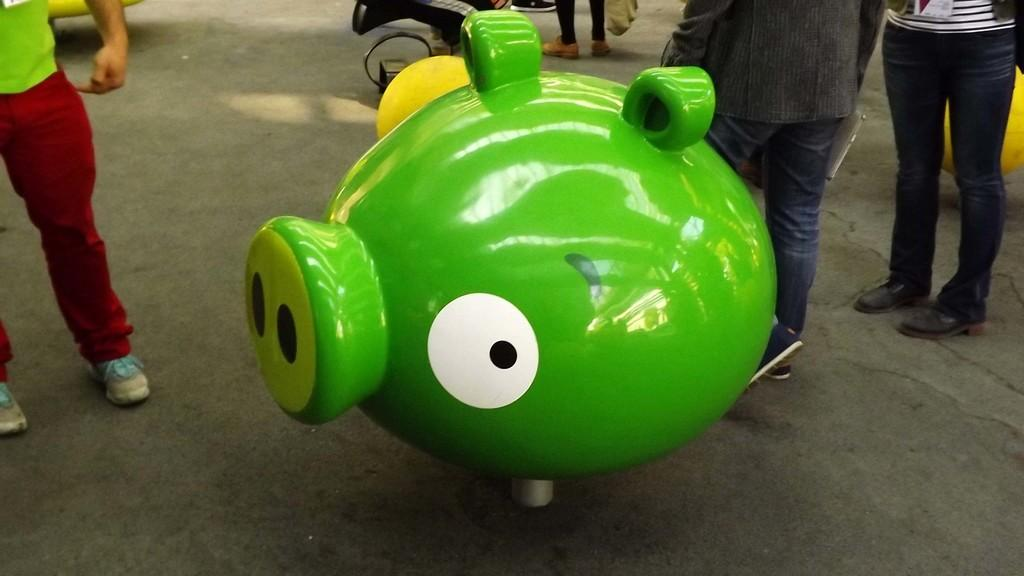What is the main subject of the image? The main subject of the image is a sculpture of a pig head. Can you describe the appearance of the sculpture? The sculpture is green in color. Are there any people visible in the image? Yes, there are people standing on the land in the image. What type of paper is being used for the selection process in the image? There is no paper or selection process present in the image; it features a green sculpture of a pig head and people standing on the land. 